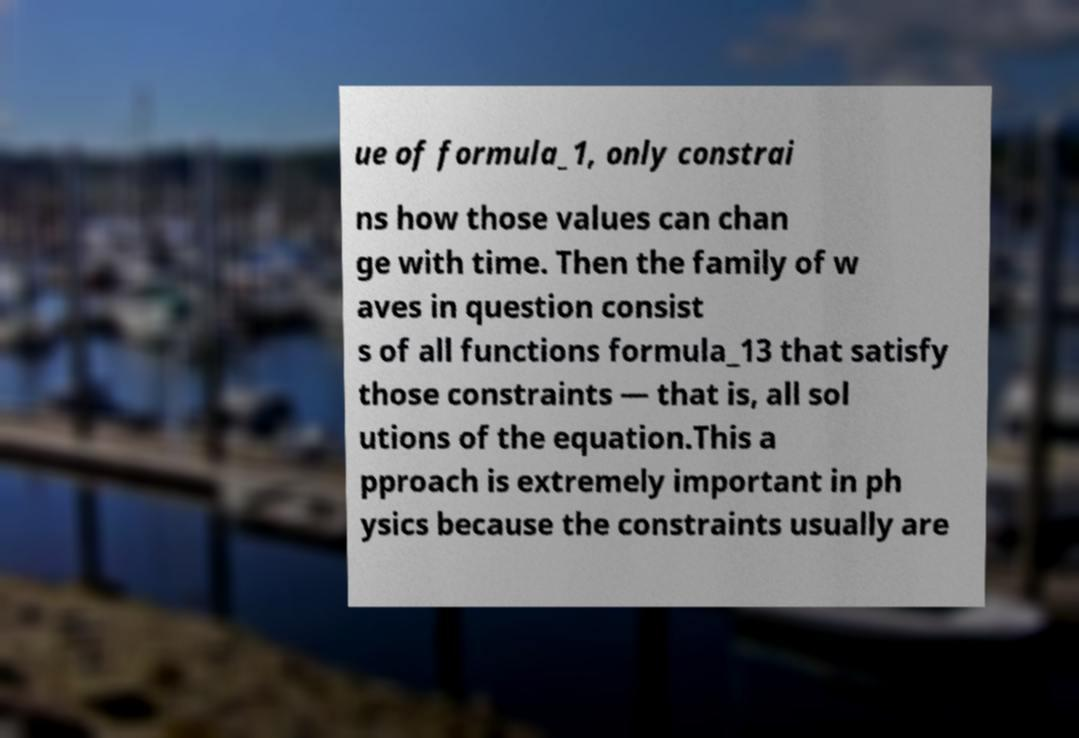For documentation purposes, I need the text within this image transcribed. Could you provide that? ue of formula_1, only constrai ns how those values can chan ge with time. Then the family of w aves in question consist s of all functions formula_13 that satisfy those constraints — that is, all sol utions of the equation.This a pproach is extremely important in ph ysics because the constraints usually are 